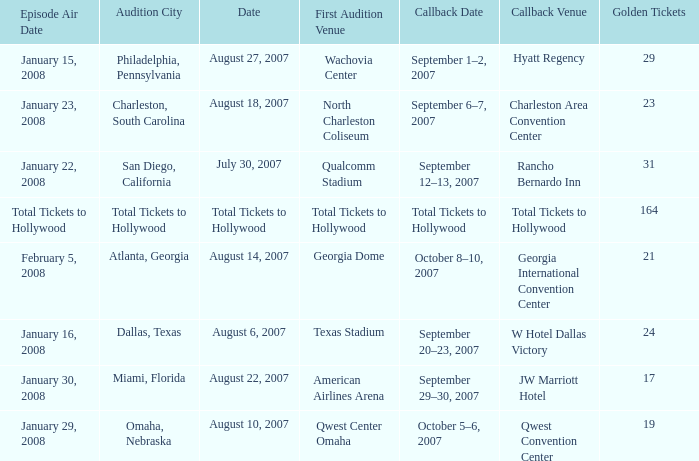What day has a callback Venue of total tickets to hollywood? Question Total Tickets to Hollywood. 